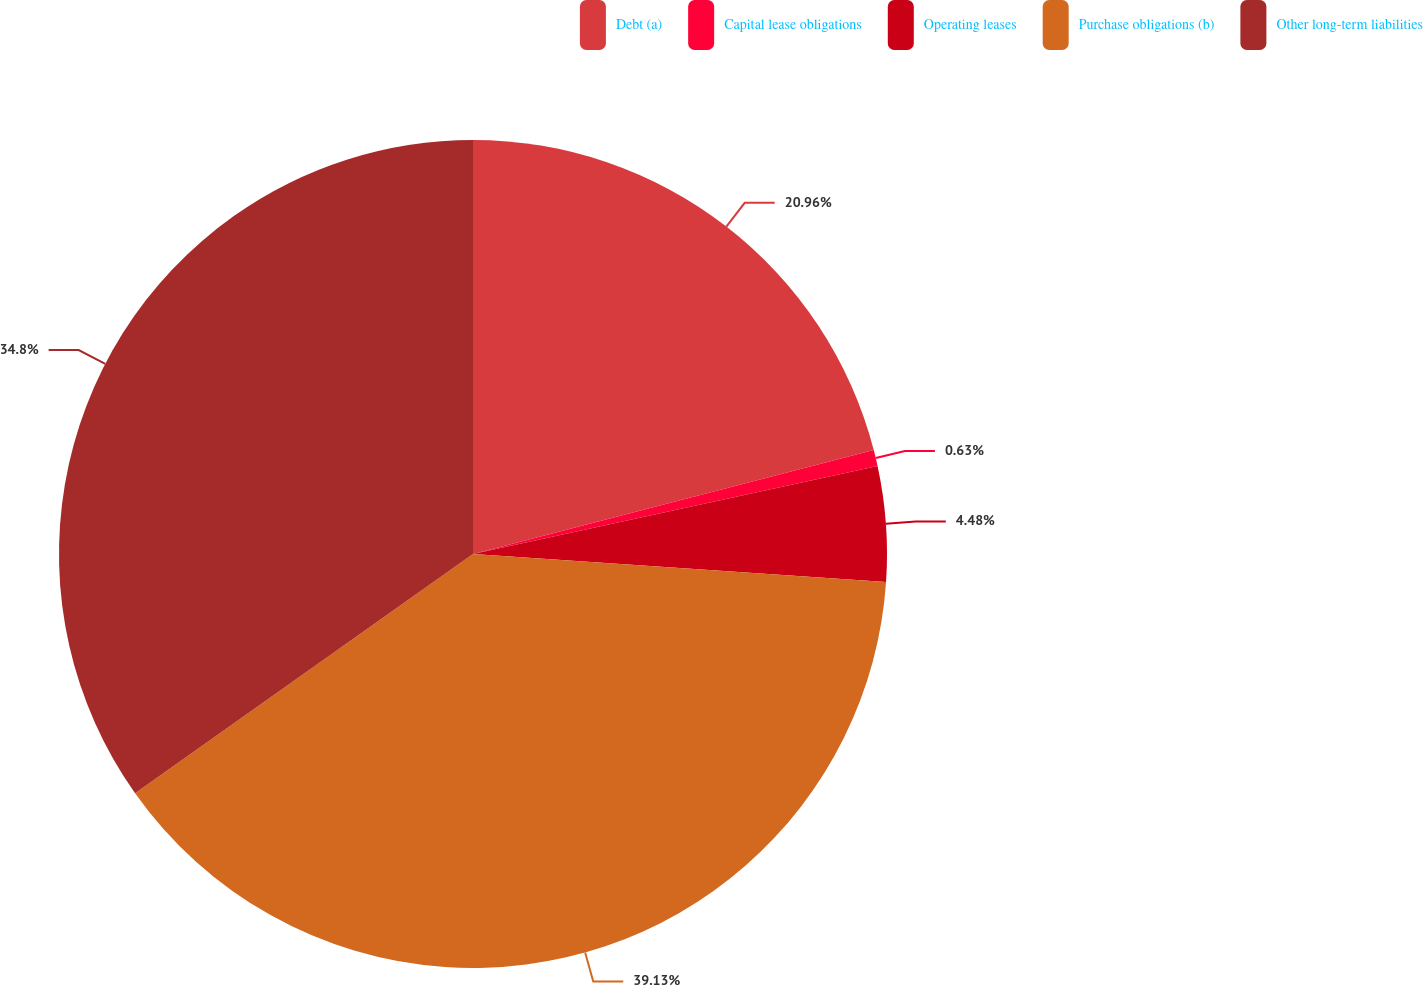Convert chart to OTSL. <chart><loc_0><loc_0><loc_500><loc_500><pie_chart><fcel>Debt (a)<fcel>Capital lease obligations<fcel>Operating leases<fcel>Purchase obligations (b)<fcel>Other long-term liabilities<nl><fcel>20.96%<fcel>0.63%<fcel>4.48%<fcel>39.12%<fcel>34.8%<nl></chart> 